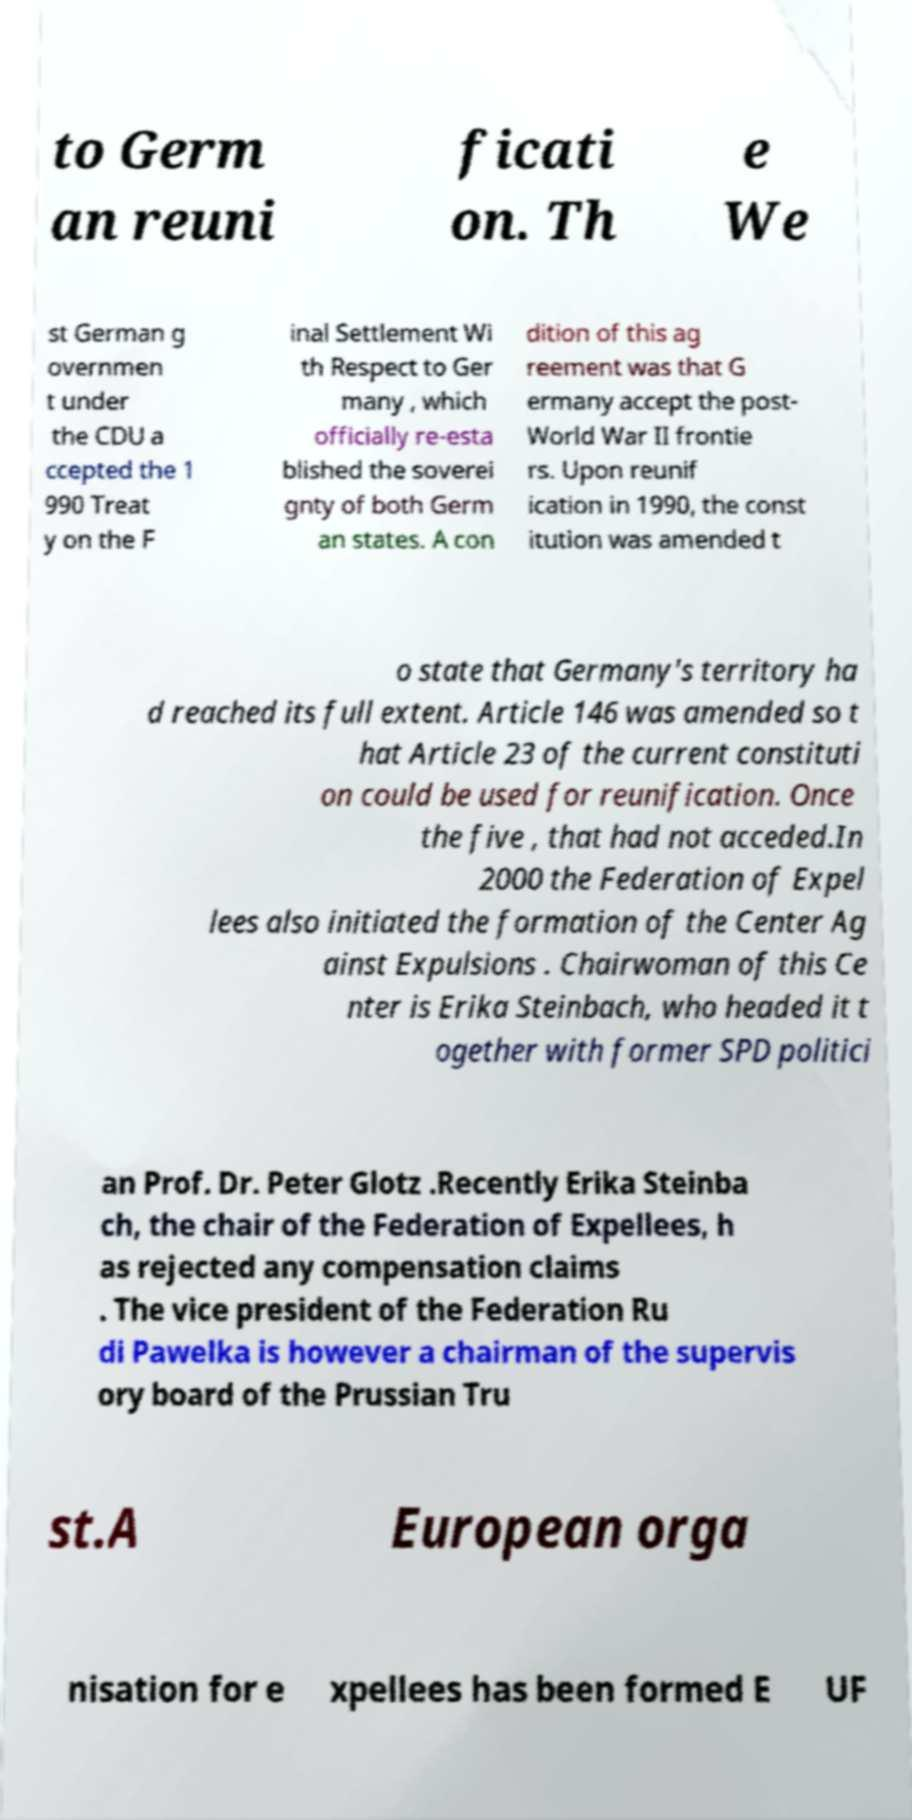Could you extract and type out the text from this image? to Germ an reuni ficati on. Th e We st German g overnmen t under the CDU a ccepted the 1 990 Treat y on the F inal Settlement Wi th Respect to Ger many , which officially re-esta blished the soverei gnty of both Germ an states. A con dition of this ag reement was that G ermany accept the post- World War II frontie rs. Upon reunif ication in 1990, the const itution was amended t o state that Germany's territory ha d reached its full extent. Article 146 was amended so t hat Article 23 of the current constituti on could be used for reunification. Once the five , that had not acceded.In 2000 the Federation of Expel lees also initiated the formation of the Center Ag ainst Expulsions . Chairwoman of this Ce nter is Erika Steinbach, who headed it t ogether with former SPD politici an Prof. Dr. Peter Glotz .Recently Erika Steinba ch, the chair of the Federation of Expellees, h as rejected any compensation claims . The vice president of the Federation Ru di Pawelka is however a chairman of the supervis ory board of the Prussian Tru st.A European orga nisation for e xpellees has been formed E UF 